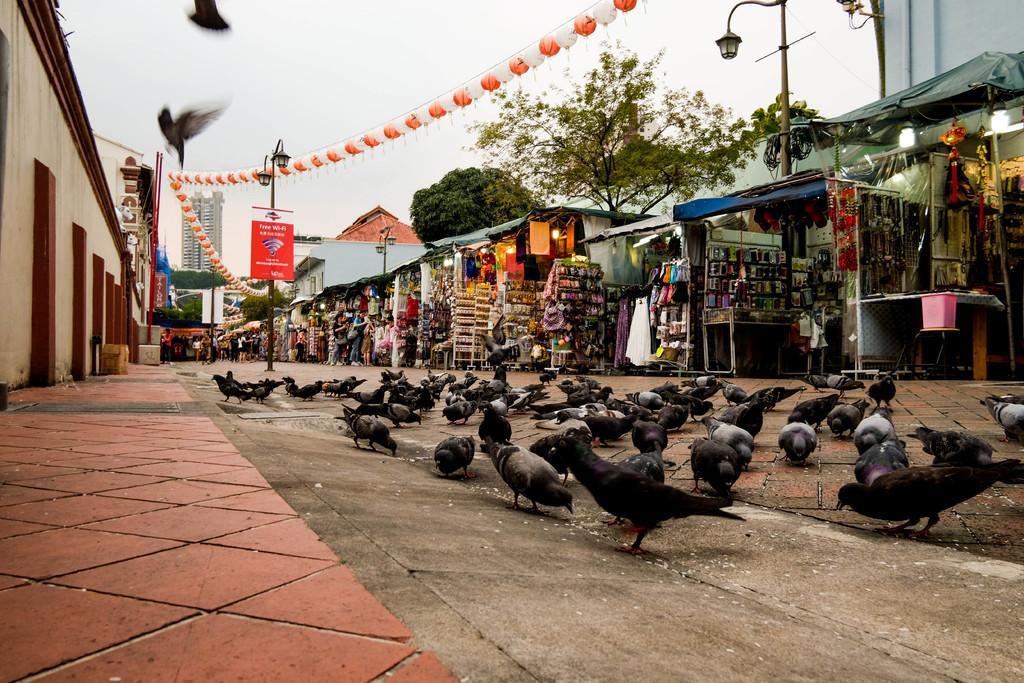Could you give a brief overview of what you see in this image? This is an outside view. At the bottom there are many pigeons on the road. On the left side, I can see the footpath and a wall. In the background there are many stalls and few people are standing. In the background there are few light poles, trees and buildings. Here I can see few birds are flying. At the top of the image I can see the sky. 